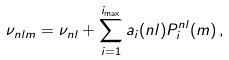Convert formula to latex. <formula><loc_0><loc_0><loc_500><loc_500>\nu _ { n l m } = \nu _ { n l } + \sum _ { i = 1 } ^ { i _ { \max } } a _ { i } ( n l ) P _ { i } ^ { n l } ( m ) \, ,</formula> 